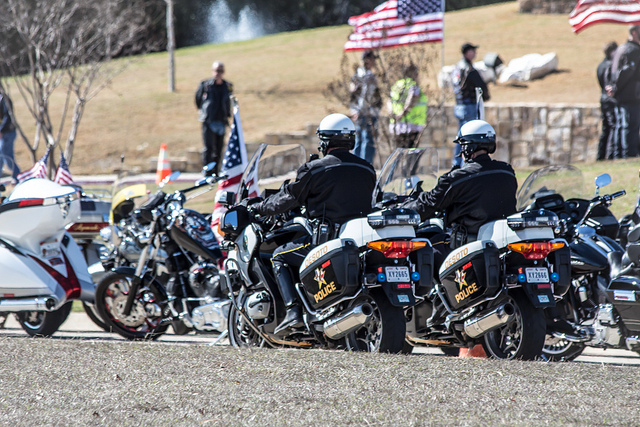Identify and read out the text in this image. POLICE POLICE 